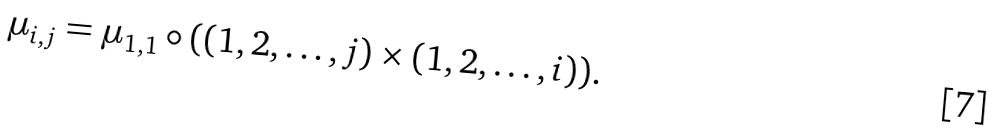<formula> <loc_0><loc_0><loc_500><loc_500>\mu _ { i , j } = \mu _ { 1 , 1 } \circ ( ( 1 , 2 , \dots , j ) \times ( 1 , 2 , \dots , i ) ) .</formula> 